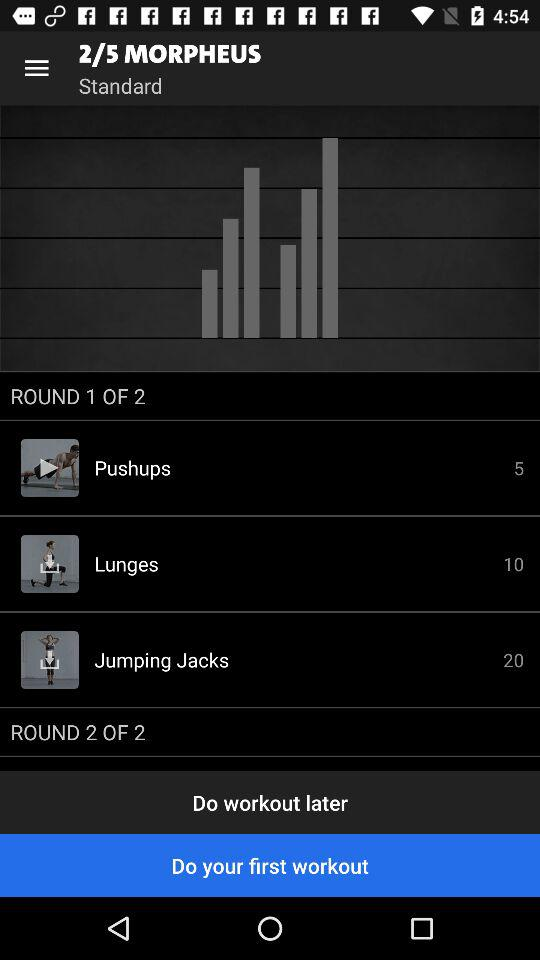What is the total number of rounds in the Morpheus workout? The total number of rounds in the Morpheus workout is 5. 